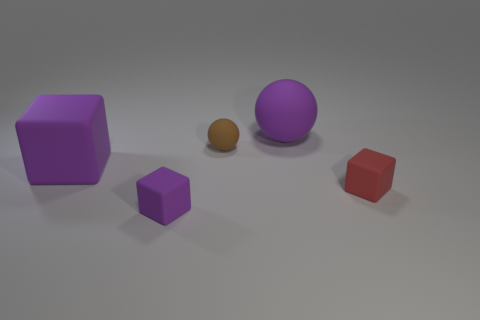Does the large purple thing behind the large purple cube have the same material as the small object that is behind the large purple block?
Provide a succinct answer. Yes. What material is the tiny ball?
Offer a terse response. Rubber. What number of big purple matte things have the same shape as the red matte object?
Offer a terse response. 1. What material is the tiny cube that is the same color as the big ball?
Your answer should be compact. Rubber. Are there any other things that are the same shape as the brown thing?
Your response must be concise. Yes. What color is the rubber block on the right side of the purple cube that is right of the purple cube that is behind the tiny red rubber object?
Ensure brevity in your answer.  Red. How many small things are either brown spheres or purple matte things?
Your answer should be compact. 2. Are there an equal number of tiny purple blocks that are to the left of the big rubber cube and small brown cylinders?
Provide a short and direct response. Yes. There is a tiny purple object; are there any big purple spheres in front of it?
Offer a very short reply. No. What number of matte objects are either blocks or small balls?
Your answer should be very brief. 4. 